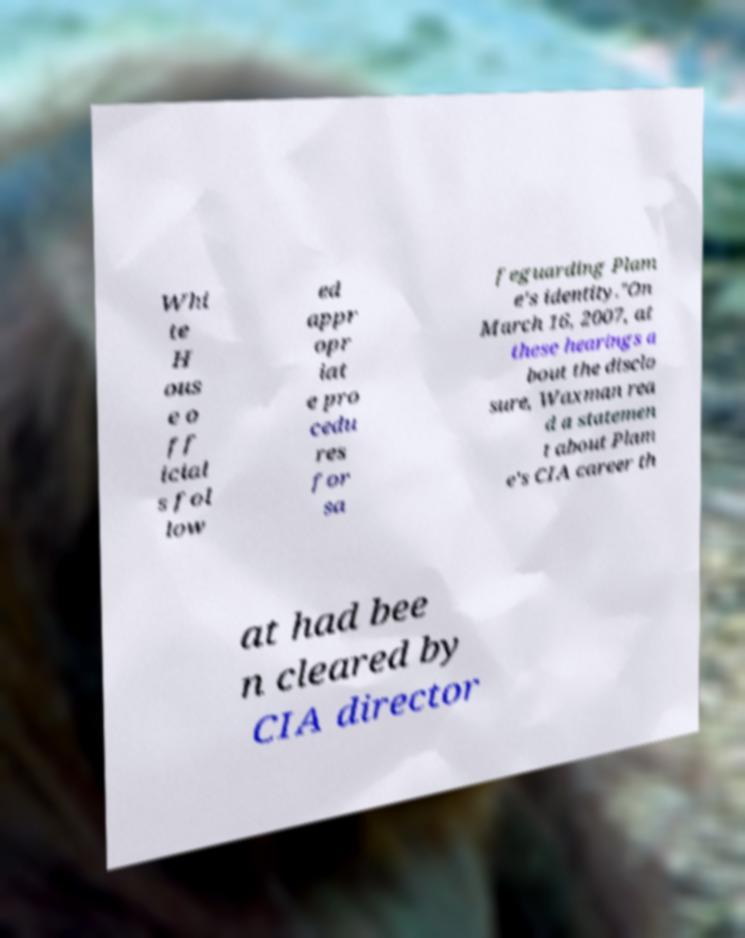I need the written content from this picture converted into text. Can you do that? Whi te H ous e o ff icial s fol low ed appr opr iat e pro cedu res for sa feguarding Plam e's identity."On March 16, 2007, at these hearings a bout the disclo sure, Waxman rea d a statemen t about Plam e's CIA career th at had bee n cleared by CIA director 